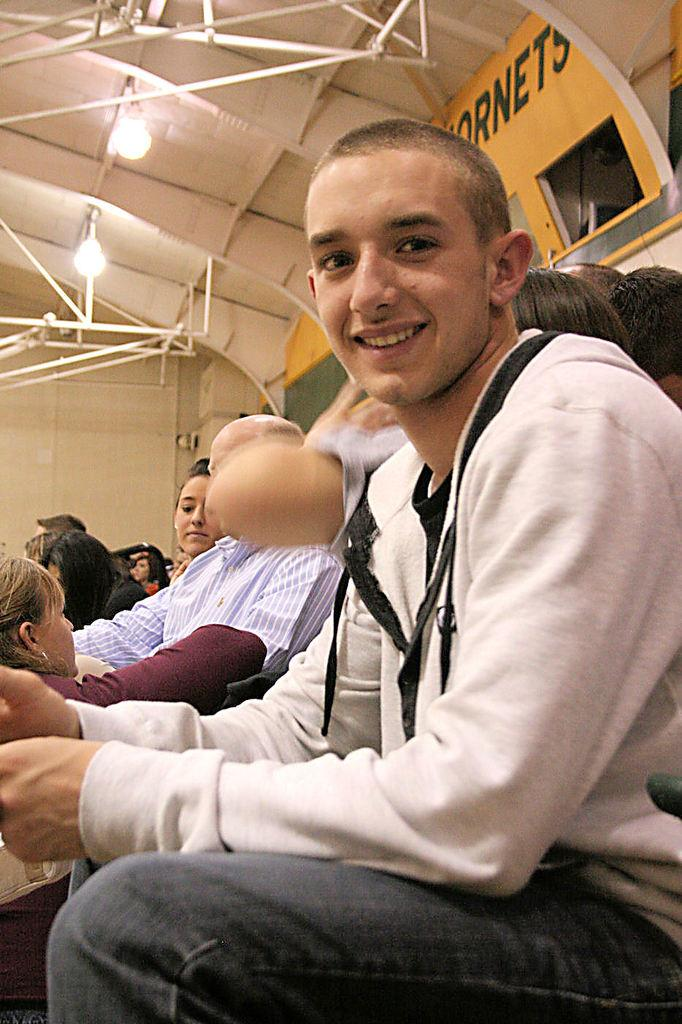How many people are in the image? There is a group of people in the image. What are the people in the image doing? The people are seated. Can you describe the facial expression of one of the people in the image? There is a man in the image who is smiling. What type of lighting is present in the image? There are lights visible in the image. What material can be seen in the image? There are metal rods in the image. What type of button is being used to control the liquid in the image? There is no button or liquid present in the image. 